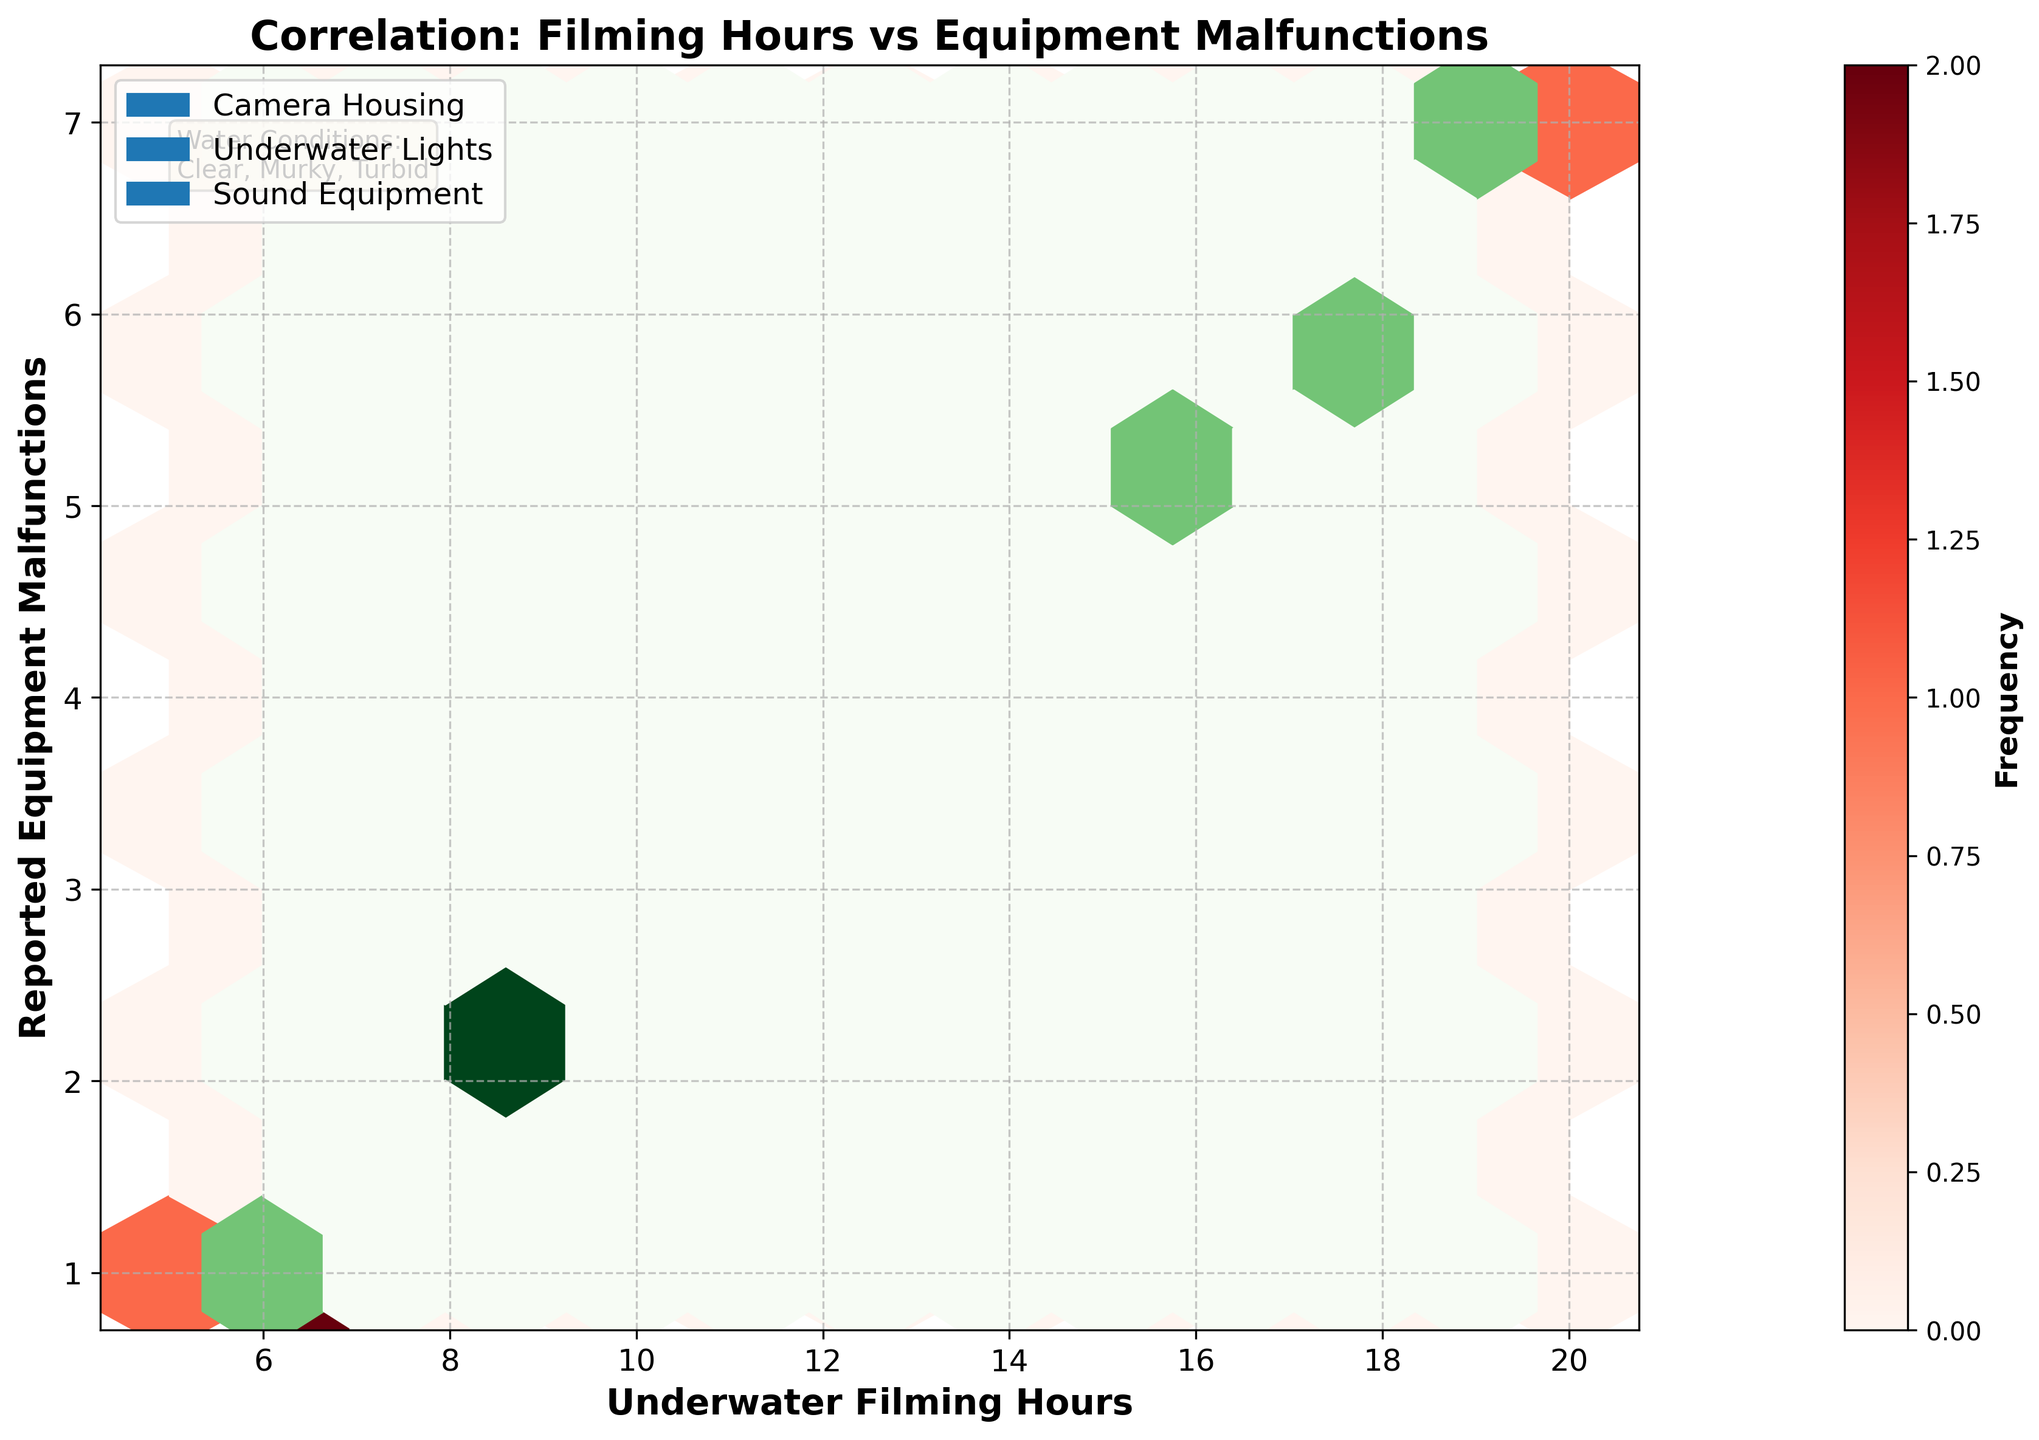What's the title of the figure? The title is typically found at the top of the figure. In this case, the plot is titled "Correlation: Filming Hours vs Equipment Malfunctions".
Answer: Correlation: Filming Hours vs Equipment Malfunctions What does the x-axis represent? The label on the x-axis indicates the metric it represents. Here, the x-axis is labeled "Underwater Filming Hours".
Answer: Underwater Filming Hours What is the color used for the hexbin plots of Sound Equipment? The colors of the hexbin plots represent different equipment types. Green is used for "Sound Equipment" as listed in the code.
Answer: Green How many equipment types are plotted? The legend at the top left of the plot lists all the equipment types being plotted. There are three: Camera Housing, Underwater Lights, and Sound Equipment.
Answer: Three What equipment type shows the highest reported malfunctions for the most filming hours? By examining the higher end of the x-axis and y-axis, Camera Housing in the Reds hexbin plot reaches the highest malfunctions for the most filming hours.
Answer: Camera Housing Which water condition is not explicitly mentioned in the color-coded hexbin plots? The textual box on the top right corner of the figure lists "Clear, Murky, Turbid" as water conditions. These conditions are not color-coded in the hexbin plots.
Answer: Water conditions Which equipment type appears to experience equipment malfunctions more frequently as filming hours increase? By observing the density and the hexbin color intensities as filming hours increase, Camera Housing (reds) and Sound Equipment (greens) malfunctions appear with higher frequencies. However, Camera Housing shows a more frequent increase.
Answer: Camera Housing Are malfunctions evenly distributed across filming hours and equipment types? By observing the hexbin density, it is clear malfunctions are not evenly distributed. They tend to increase with more filming hours, especially for Camera Housing and Sound Equipment.
Answer: No Does any equipment type seem to have a consistently high frequency of malfunctions in specific water conditions? The figure does not directly categorize by water condition inside the plot areas, considering the hexbin data. Thus, no direct water condition-specific frequency can be deduced solely from the plot area.
Answer: No Which two water conditions are explicitly listed in the text box at the plot's top right corner? The water condition text box lists three conditions: Clear, Murky, and Turbid. Clear and Murky are explicitly mentioned in the "water_conditions" data column.
Answer: Clear, Murky 